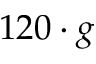<formula> <loc_0><loc_0><loc_500><loc_500>1 2 0 \cdot g</formula> 